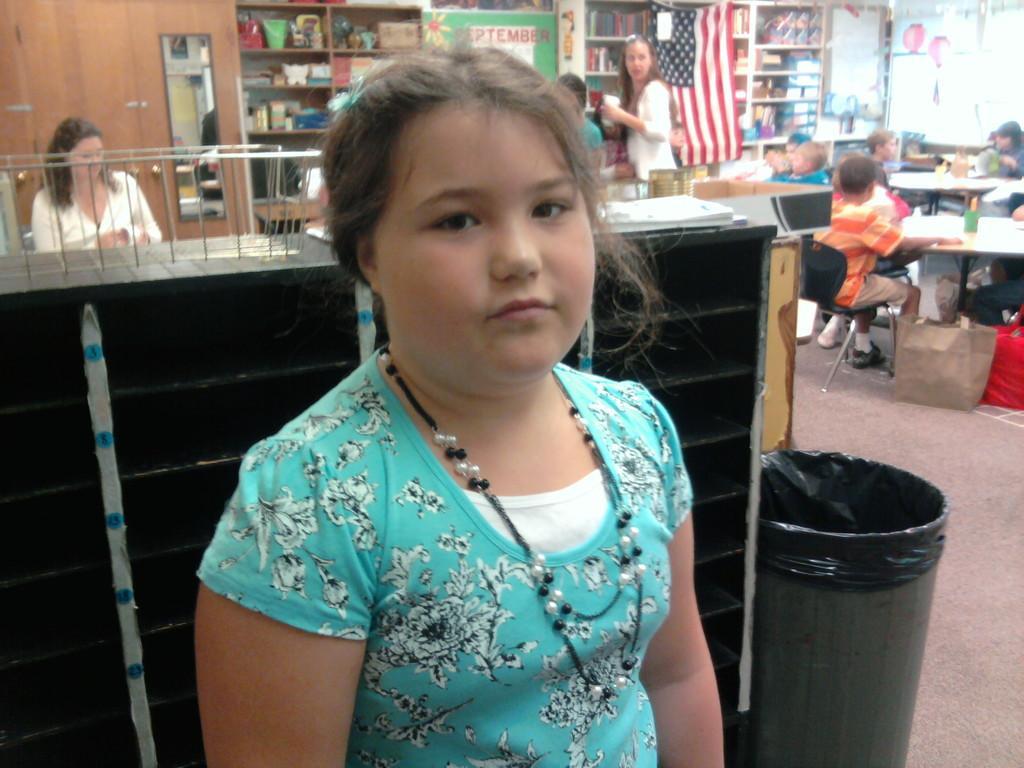In one or two sentences, can you explain what this image depicts? A girl is standing posing to camera with some people in her background. 